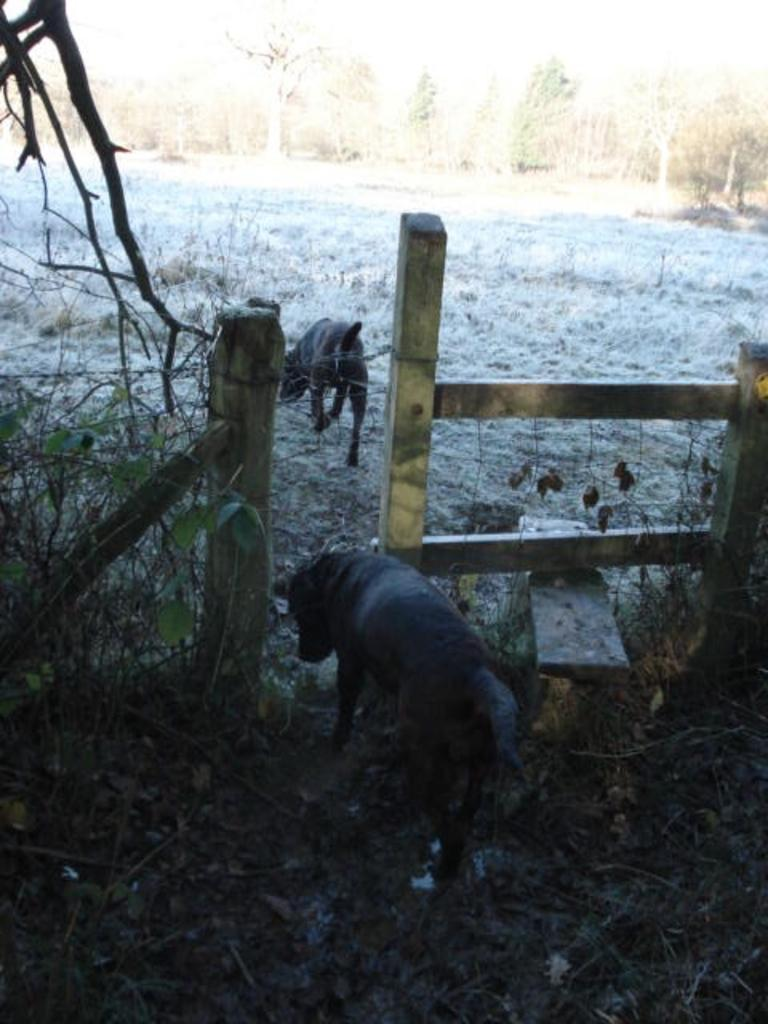What type of animals are present in the image? There are dogs in the image. What can be seen in the background of the image? Trees are visible in the image. What type of ground cover is present in the image? There is grass on the ground in the image. What type of jar can be seen on the border of the image? There is no jar or border present in the image; it features dogs and a natural setting with trees and grass. 